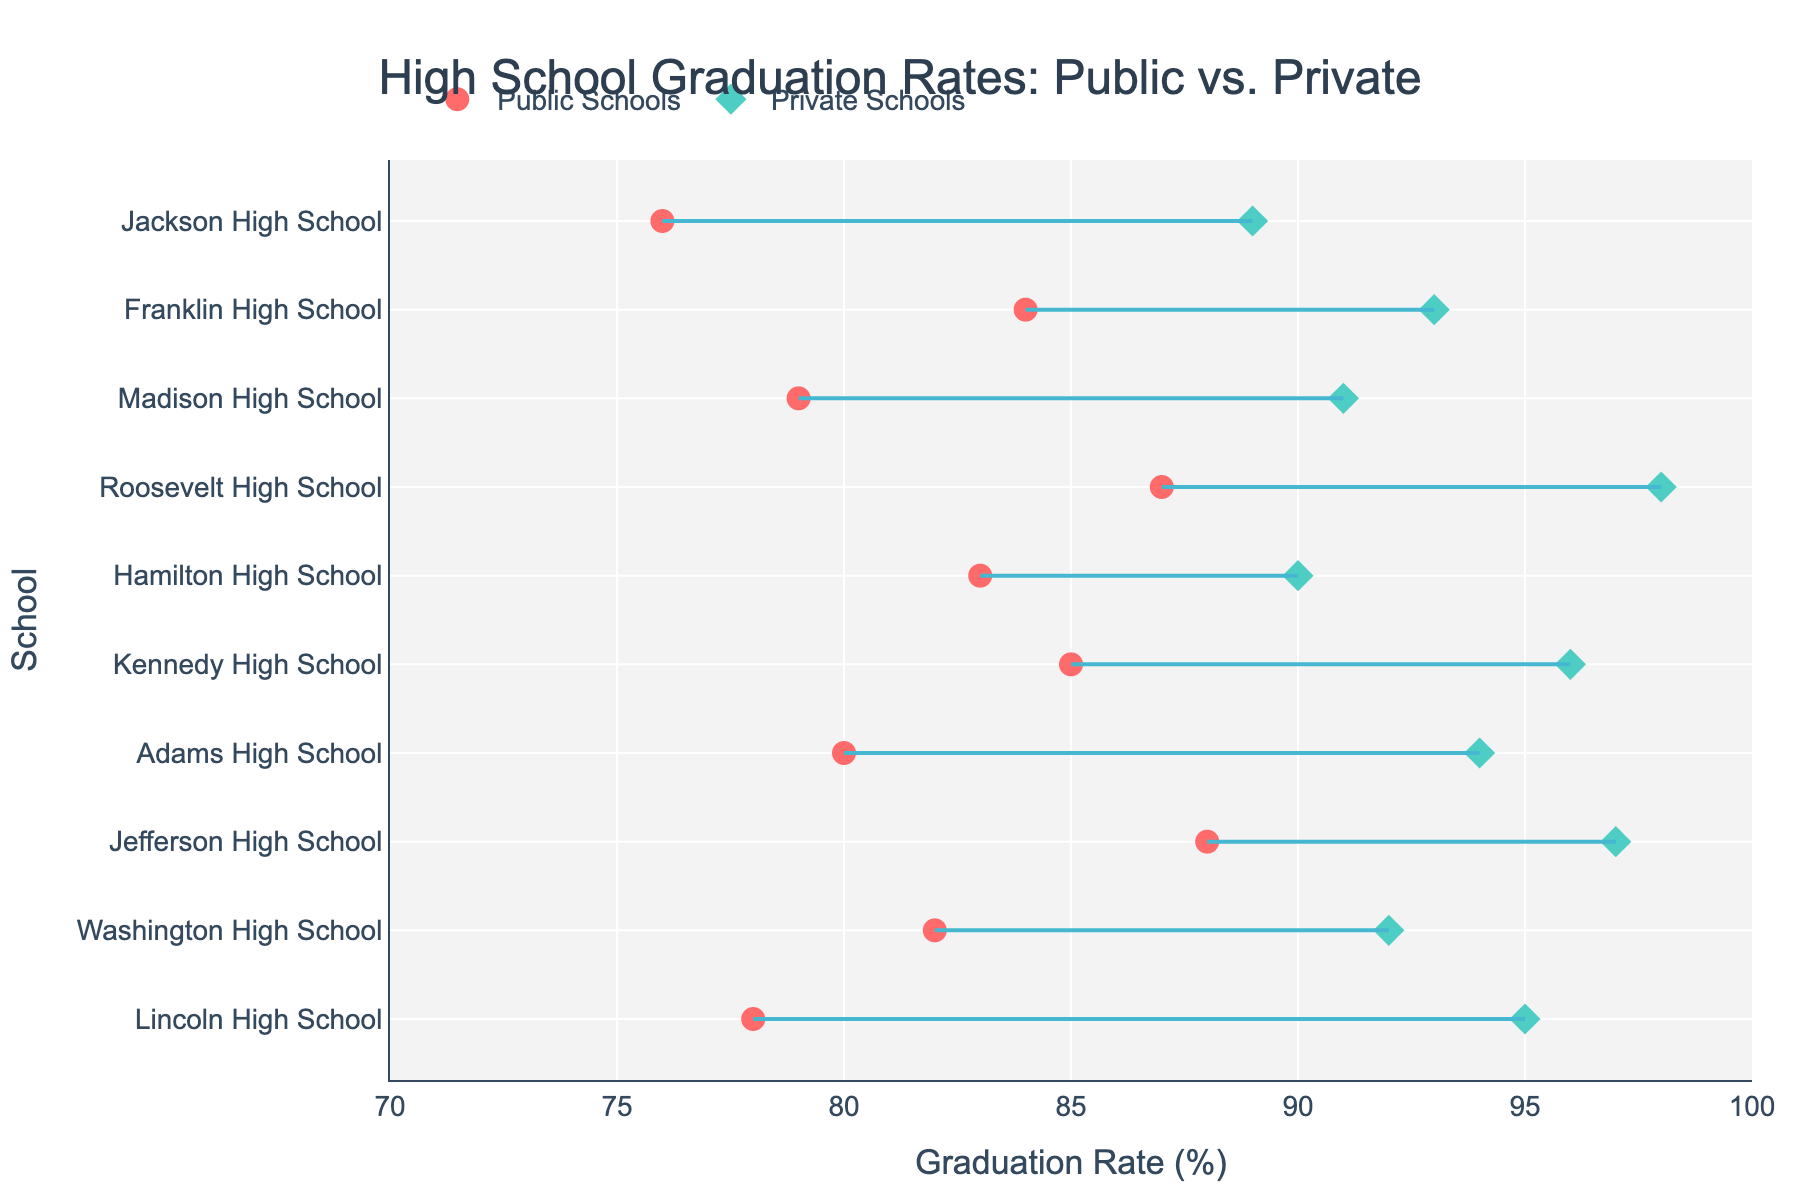What is the title of the plot? The title is usually at the top center of the plot. In this case, it is stated in the code.
Answer: High School Graduation Rates: Public vs. Private How many schools are compared in the plot? Count the number of different school names listed along the y-axis.
Answer: 10 Which school has the highest private school graduation rate? Look for the highest value on the x-axis for the private school data points (marked by diamonds) and find the corresponding school on the y-axis.
Answer: Roosevelt High School What is the graduation rate difference between public and private schools for Jackson High School? Locate Jackson High School on the y-axis, then find the public rate and private rate on the x-axis, and subtract the public rate from the private rate.
Answer: 13% Which school has the smallest difference in graduation rates between public and private schools? Measure the length of the lines connecting the public and private rates for each school. The smallest gap corresponds to the smallest difference.
Answer: Hamilton High School What is the average public school graduation rate across all schools? Sum all the public graduation rates and divide by the number of schools. (78 + 82 + 88 + 80 + 85 + 83 + 87 + 79 + 84 + 76) / 10 = 83.2%
Answer: 83.2% Is there any school where the public graduation rate is higher than the private graduation rate? Compare each public rate to its corresponding private rate. None of the public rates exceed the private rates listed.
Answer: No Which school has the lowest public school graduation rate? Look for the lowest value on the x-axis for the public school data points (marked by circles) and find the corresponding school on the y-axis.
Answer: Jackson High School How much higher is Jefferson High School's private graduation rate compared to its public graduation rate? Locate Jefferson High School, then find the public rate and private rate on the x-axis, and subtract the public rate from the private rate.
Answer: 9% What is the median private school graduation rate? List all private graduation rates and find the middle value after ordering these rates. (Sorted list: 89, 90, 91, 92, 93, 94, 95, 96, 97, 98)
Answer: 94.5% 